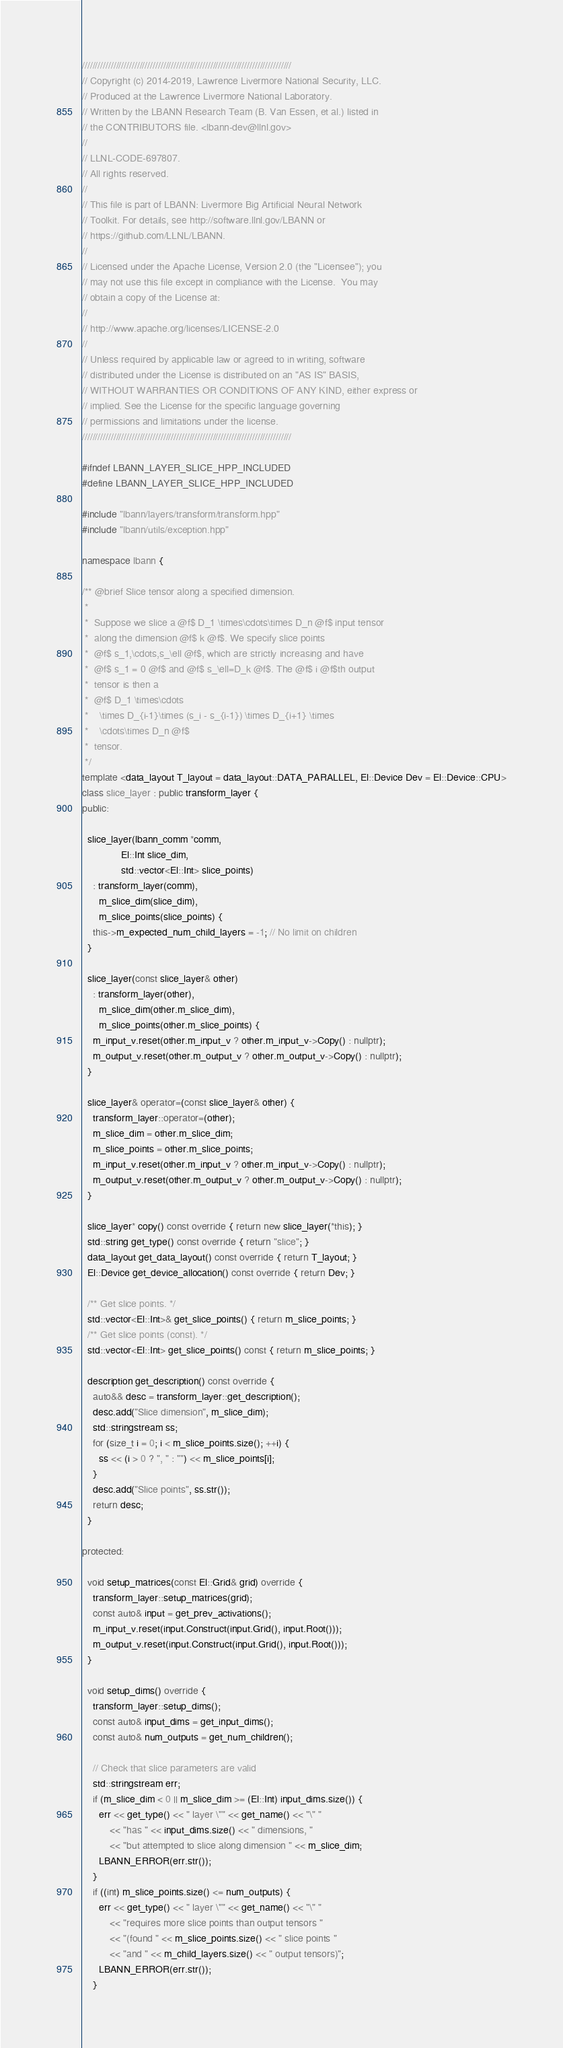Convert code to text. <code><loc_0><loc_0><loc_500><loc_500><_C++_>////////////////////////////////////////////////////////////////////////////////
// Copyright (c) 2014-2019, Lawrence Livermore National Security, LLC.
// Produced at the Lawrence Livermore National Laboratory.
// Written by the LBANN Research Team (B. Van Essen, et al.) listed in
// the CONTRIBUTORS file. <lbann-dev@llnl.gov>
//
// LLNL-CODE-697807.
// All rights reserved.
//
// This file is part of LBANN: Livermore Big Artificial Neural Network
// Toolkit. For details, see http://software.llnl.gov/LBANN or
// https://github.com/LLNL/LBANN.
//
// Licensed under the Apache License, Version 2.0 (the "Licensee"); you
// may not use this file except in compliance with the License.  You may
// obtain a copy of the License at:
//
// http://www.apache.org/licenses/LICENSE-2.0
//
// Unless required by applicable law or agreed to in writing, software
// distributed under the License is distributed on an "AS IS" BASIS,
// WITHOUT WARRANTIES OR CONDITIONS OF ANY KIND, either express or
// implied. See the License for the specific language governing
// permissions and limitations under the license.
////////////////////////////////////////////////////////////////////////////////

#ifndef LBANN_LAYER_SLICE_HPP_INCLUDED
#define LBANN_LAYER_SLICE_HPP_INCLUDED

#include "lbann/layers/transform/transform.hpp"
#include "lbann/utils/exception.hpp"

namespace lbann {

/** @brief Slice tensor along a specified dimension.
 *
 *  Suppose we slice a @f$ D_1 \times\cdots\times D_n @f$ input tensor
 *  along the dimension @f$ k @f$. We specify slice points
 *  @f$ s_1,\cdots,s_\ell @f$, which are strictly increasing and have
 *  @f$ s_1 = 0 @f$ and @f$ s_\ell=D_k @f$. The @f$ i @f$th output
 *  tensor is then a
 *  @f$ D_1 \times\cdots
 *    \times D_{i-1}\times (s_i - s_{i-1}) \times D_{i+1} \times
 *    \cdots\times D_n @f$
 *  tensor.
 */
template <data_layout T_layout = data_layout::DATA_PARALLEL, El::Device Dev = El::Device::CPU>
class slice_layer : public transform_layer {
public:

  slice_layer(lbann_comm *comm,
              El::Int slice_dim,
              std::vector<El::Int> slice_points)
    : transform_layer(comm),
      m_slice_dim(slice_dim),
      m_slice_points(slice_points) {
    this->m_expected_num_child_layers = -1; // No limit on children
  }

  slice_layer(const slice_layer& other)
    : transform_layer(other),
      m_slice_dim(other.m_slice_dim),
      m_slice_points(other.m_slice_points) {
    m_input_v.reset(other.m_input_v ? other.m_input_v->Copy() : nullptr);
    m_output_v.reset(other.m_output_v ? other.m_output_v->Copy() : nullptr);
  }

  slice_layer& operator=(const slice_layer& other) {
    transform_layer::operator=(other);
    m_slice_dim = other.m_slice_dim;
    m_slice_points = other.m_slice_points;
    m_input_v.reset(other.m_input_v ? other.m_input_v->Copy() : nullptr);
    m_output_v.reset(other.m_output_v ? other.m_output_v->Copy() : nullptr);
  }

  slice_layer* copy() const override { return new slice_layer(*this); }
  std::string get_type() const override { return "slice"; }
  data_layout get_data_layout() const override { return T_layout; }
  El::Device get_device_allocation() const override { return Dev; }

  /** Get slice points. */
  std::vector<El::Int>& get_slice_points() { return m_slice_points; }
  /** Get slice points (const). */
  std::vector<El::Int> get_slice_points() const { return m_slice_points; }

  description get_description() const override {
    auto&& desc = transform_layer::get_description();
    desc.add("Slice dimension", m_slice_dim);
    std::stringstream ss;
    for (size_t i = 0; i < m_slice_points.size(); ++i) {
      ss << (i > 0 ? ", " : "") << m_slice_points[i];
    }
    desc.add("Slice points", ss.str());
    return desc;
  }

protected:

  void setup_matrices(const El::Grid& grid) override {
    transform_layer::setup_matrices(grid);
    const auto& input = get_prev_activations();
    m_input_v.reset(input.Construct(input.Grid(), input.Root()));
    m_output_v.reset(input.Construct(input.Grid(), input.Root()));
  }

  void setup_dims() override {
    transform_layer::setup_dims();
    const auto& input_dims = get_input_dims();
    const auto& num_outputs = get_num_children();

    // Check that slice parameters are valid
    std::stringstream err;
    if (m_slice_dim < 0 || m_slice_dim >= (El::Int) input_dims.size()) {
      err << get_type() << " layer \"" << get_name() << "\" "
          << "has " << input_dims.size() << " dimensions, "
          << "but attempted to slice along dimension " << m_slice_dim;
      LBANN_ERROR(err.str());
    }
    if ((int) m_slice_points.size() <= num_outputs) {
      err << get_type() << " layer \"" << get_name() << "\" "
          << "requires more slice points than output tensors "
          << "(found " << m_slice_points.size() << " slice points "
          << "and " << m_child_layers.size() << " output tensors)";
      LBANN_ERROR(err.str());
    }</code> 